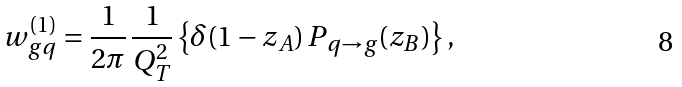Convert formula to latex. <formula><loc_0><loc_0><loc_500><loc_500>w _ { g q } ^ { ( 1 ) } = \frac { 1 } { 2 \pi } \, \frac { 1 } { Q _ { T } ^ { 2 } } \left \{ \delta ( 1 - z _ { A } ) \, P _ { q \rightarrow g } ( z _ { B } ) \right \} ,</formula> 